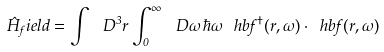<formula> <loc_0><loc_0><loc_500><loc_500>\hat { H } _ { f } i e l d = \int \, \ D ^ { 3 } { r } \int _ { 0 } ^ { \infty } \, \ D \omega \, \hbar { \omega } \, \ h b { f } ^ { \dagger } ( { r } , \omega ) \cdot \ h b { f } ( { r } , \omega )</formula> 